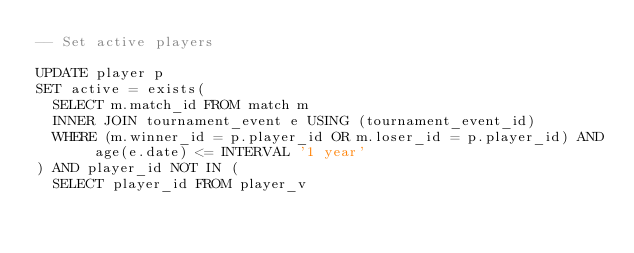Convert code to text. <code><loc_0><loc_0><loc_500><loc_500><_SQL_>-- Set active players

UPDATE player p
SET active = exists(
	SELECT m.match_id FROM match m
	INNER JOIN tournament_event e USING (tournament_event_id)
	WHERE (m.winner_id = p.player_id OR m.loser_id = p.player_id) AND age(e.date) <= INTERVAL '1 year'
) AND player_id NOT IN (
	SELECT player_id FROM player_v</code> 